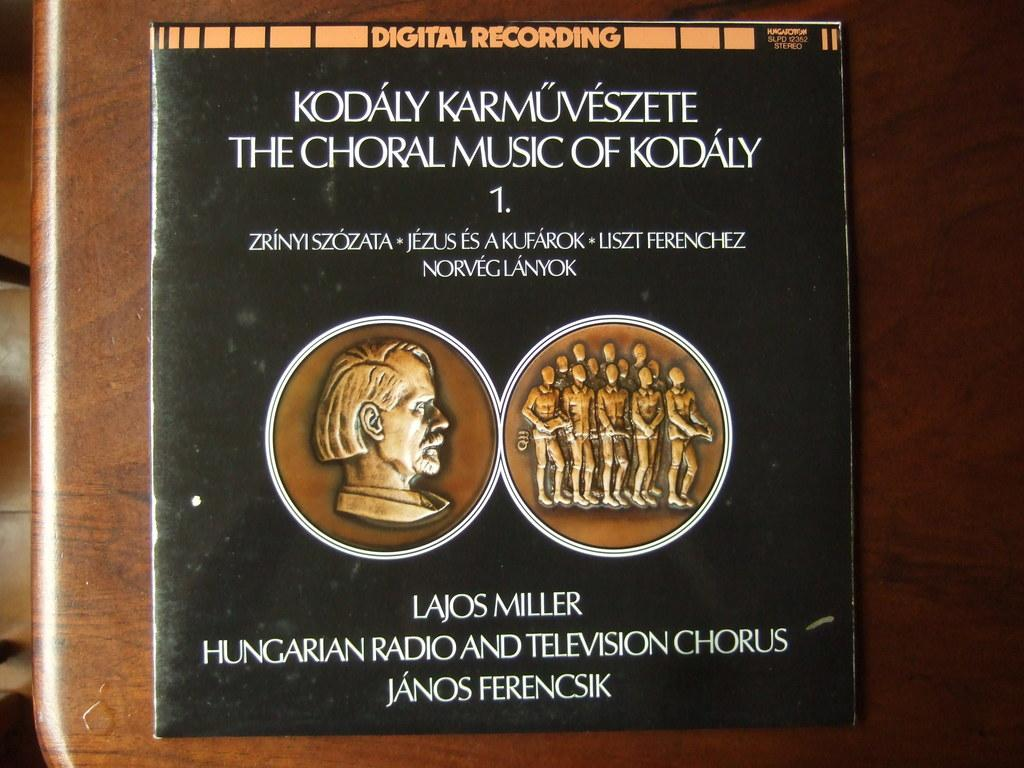<image>
Give a short and clear explanation of the subsequent image. A vinyl record of The Choral Music of Kodaly by Lajos Miller and Janos Ferencsik. 